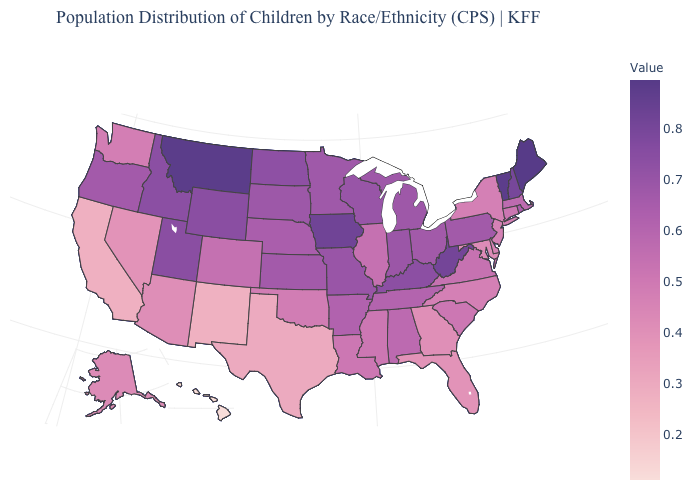Which states hav the highest value in the MidWest?
Give a very brief answer. Iowa. Is the legend a continuous bar?
Write a very short answer. Yes. Which states hav the highest value in the Northeast?
Concise answer only. Maine. Which states have the lowest value in the USA?
Answer briefly. Hawaii. 